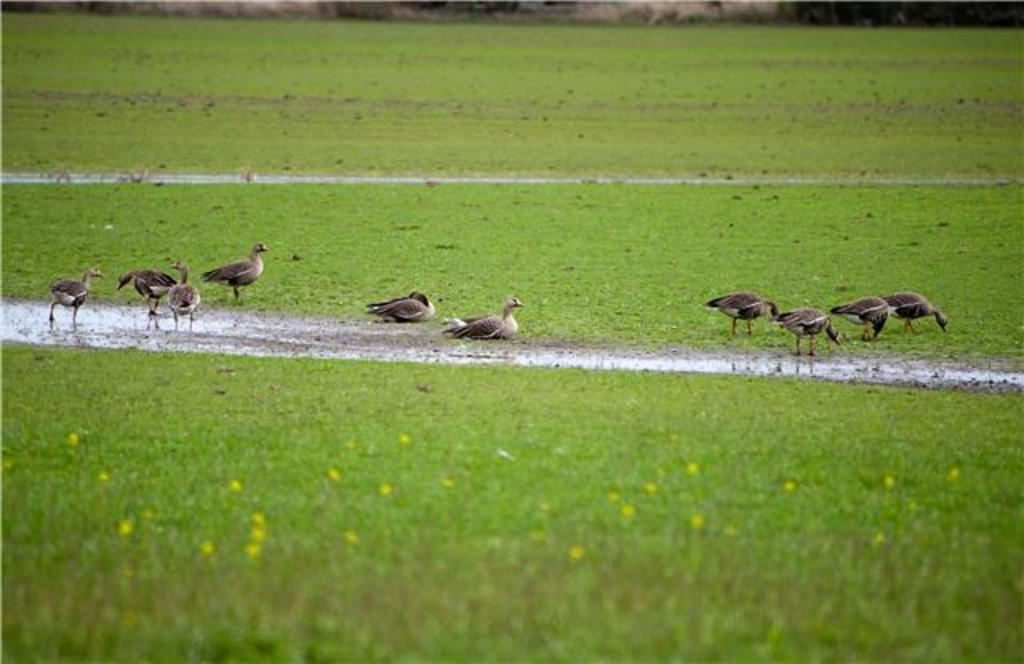What type of vegetation is in the foreground of the image? There is grass and flowers in the foreground of the image. What can be seen in the middle of the image? There are birds, grass, and mud in the middle of the image. What is visible in the background of the image? There is grass and other plants in the background of the image. Can you tell me how many bushes are present in the image? There is no mention of bushes in the provided facts, so it cannot be determined how many bushes are present in the image. Is there a guide in the image to help the birds navigate? There is no mention of a guide or any navigational assistance for the birds in the image. 